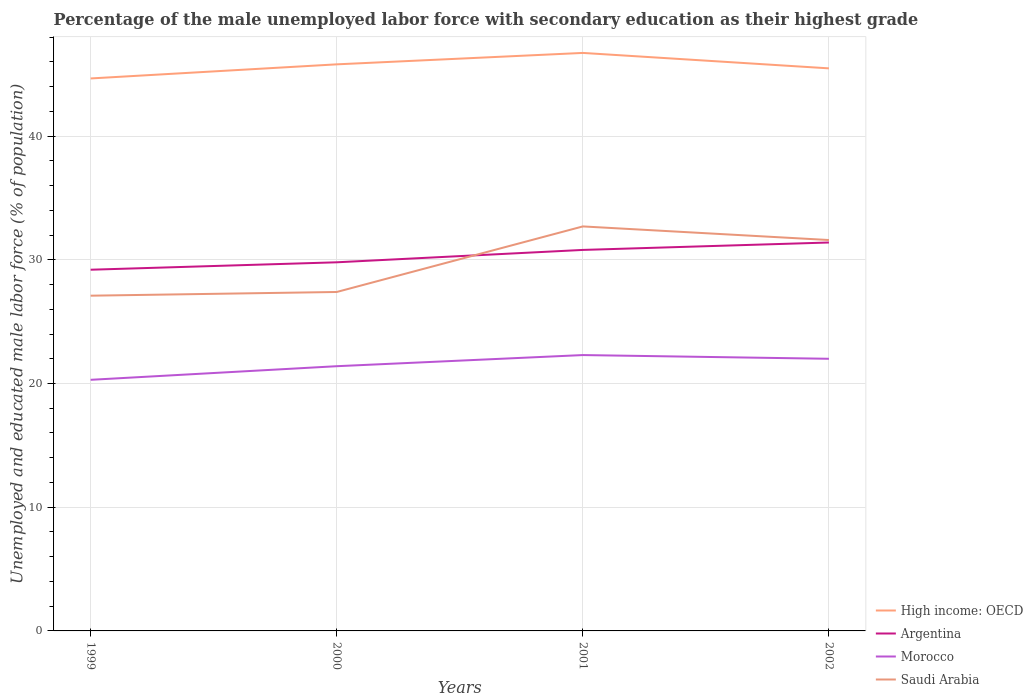Across all years, what is the maximum percentage of the unemployed male labor force with secondary education in Argentina?
Your answer should be very brief. 29.2. What is the total percentage of the unemployed male labor force with secondary education in High income: OECD in the graph?
Your answer should be very brief. -0.92. What is the difference between the highest and the second highest percentage of the unemployed male labor force with secondary education in Morocco?
Your answer should be very brief. 2. What is the difference between the highest and the lowest percentage of the unemployed male labor force with secondary education in Morocco?
Your answer should be compact. 2. Is the percentage of the unemployed male labor force with secondary education in High income: OECD strictly greater than the percentage of the unemployed male labor force with secondary education in Morocco over the years?
Provide a succinct answer. No. How many lines are there?
Provide a short and direct response. 4. Are the values on the major ticks of Y-axis written in scientific E-notation?
Your answer should be compact. No. Does the graph contain any zero values?
Give a very brief answer. No. Does the graph contain grids?
Give a very brief answer. Yes. Where does the legend appear in the graph?
Make the answer very short. Bottom right. How many legend labels are there?
Keep it short and to the point. 4. How are the legend labels stacked?
Your answer should be compact. Vertical. What is the title of the graph?
Offer a terse response. Percentage of the male unemployed labor force with secondary education as their highest grade. What is the label or title of the Y-axis?
Offer a terse response. Unemployed and educated male labor force (% of population). What is the Unemployed and educated male labor force (% of population) in High income: OECD in 1999?
Offer a terse response. 44.66. What is the Unemployed and educated male labor force (% of population) of Argentina in 1999?
Provide a short and direct response. 29.2. What is the Unemployed and educated male labor force (% of population) of Morocco in 1999?
Make the answer very short. 20.3. What is the Unemployed and educated male labor force (% of population) of Saudi Arabia in 1999?
Provide a succinct answer. 27.1. What is the Unemployed and educated male labor force (% of population) of High income: OECD in 2000?
Your answer should be compact. 45.8. What is the Unemployed and educated male labor force (% of population) in Argentina in 2000?
Give a very brief answer. 29.8. What is the Unemployed and educated male labor force (% of population) in Morocco in 2000?
Provide a succinct answer. 21.4. What is the Unemployed and educated male labor force (% of population) of Saudi Arabia in 2000?
Ensure brevity in your answer.  27.4. What is the Unemployed and educated male labor force (% of population) of High income: OECD in 2001?
Offer a very short reply. 46.73. What is the Unemployed and educated male labor force (% of population) in Argentina in 2001?
Make the answer very short. 30.8. What is the Unemployed and educated male labor force (% of population) in Morocco in 2001?
Offer a very short reply. 22.3. What is the Unemployed and educated male labor force (% of population) in Saudi Arabia in 2001?
Offer a very short reply. 32.7. What is the Unemployed and educated male labor force (% of population) of High income: OECD in 2002?
Ensure brevity in your answer.  45.48. What is the Unemployed and educated male labor force (% of population) of Argentina in 2002?
Provide a succinct answer. 31.4. What is the Unemployed and educated male labor force (% of population) of Saudi Arabia in 2002?
Keep it short and to the point. 31.6. Across all years, what is the maximum Unemployed and educated male labor force (% of population) of High income: OECD?
Make the answer very short. 46.73. Across all years, what is the maximum Unemployed and educated male labor force (% of population) in Argentina?
Your response must be concise. 31.4. Across all years, what is the maximum Unemployed and educated male labor force (% of population) in Morocco?
Your answer should be compact. 22.3. Across all years, what is the maximum Unemployed and educated male labor force (% of population) in Saudi Arabia?
Provide a short and direct response. 32.7. Across all years, what is the minimum Unemployed and educated male labor force (% of population) of High income: OECD?
Your answer should be very brief. 44.66. Across all years, what is the minimum Unemployed and educated male labor force (% of population) in Argentina?
Provide a short and direct response. 29.2. Across all years, what is the minimum Unemployed and educated male labor force (% of population) in Morocco?
Provide a short and direct response. 20.3. Across all years, what is the minimum Unemployed and educated male labor force (% of population) in Saudi Arabia?
Ensure brevity in your answer.  27.1. What is the total Unemployed and educated male labor force (% of population) in High income: OECD in the graph?
Make the answer very short. 182.67. What is the total Unemployed and educated male labor force (% of population) of Argentina in the graph?
Keep it short and to the point. 121.2. What is the total Unemployed and educated male labor force (% of population) in Morocco in the graph?
Ensure brevity in your answer.  86. What is the total Unemployed and educated male labor force (% of population) of Saudi Arabia in the graph?
Offer a very short reply. 118.8. What is the difference between the Unemployed and educated male labor force (% of population) in High income: OECD in 1999 and that in 2000?
Your answer should be compact. -1.14. What is the difference between the Unemployed and educated male labor force (% of population) in Morocco in 1999 and that in 2000?
Your answer should be very brief. -1.1. What is the difference between the Unemployed and educated male labor force (% of population) in Saudi Arabia in 1999 and that in 2000?
Offer a very short reply. -0.3. What is the difference between the Unemployed and educated male labor force (% of population) of High income: OECD in 1999 and that in 2001?
Give a very brief answer. -2.06. What is the difference between the Unemployed and educated male labor force (% of population) in Argentina in 1999 and that in 2001?
Your answer should be compact. -1.6. What is the difference between the Unemployed and educated male labor force (% of population) of Morocco in 1999 and that in 2001?
Your answer should be very brief. -2. What is the difference between the Unemployed and educated male labor force (% of population) in High income: OECD in 1999 and that in 2002?
Provide a succinct answer. -0.82. What is the difference between the Unemployed and educated male labor force (% of population) in Argentina in 1999 and that in 2002?
Keep it short and to the point. -2.2. What is the difference between the Unemployed and educated male labor force (% of population) of Saudi Arabia in 1999 and that in 2002?
Give a very brief answer. -4.5. What is the difference between the Unemployed and educated male labor force (% of population) of High income: OECD in 2000 and that in 2001?
Your answer should be very brief. -0.92. What is the difference between the Unemployed and educated male labor force (% of population) in High income: OECD in 2000 and that in 2002?
Make the answer very short. 0.32. What is the difference between the Unemployed and educated male labor force (% of population) of Argentina in 2000 and that in 2002?
Provide a succinct answer. -1.6. What is the difference between the Unemployed and educated male labor force (% of population) of High income: OECD in 2001 and that in 2002?
Keep it short and to the point. 1.25. What is the difference between the Unemployed and educated male labor force (% of population) of Argentina in 2001 and that in 2002?
Offer a terse response. -0.6. What is the difference between the Unemployed and educated male labor force (% of population) in High income: OECD in 1999 and the Unemployed and educated male labor force (% of population) in Argentina in 2000?
Offer a very short reply. 14.86. What is the difference between the Unemployed and educated male labor force (% of population) of High income: OECD in 1999 and the Unemployed and educated male labor force (% of population) of Morocco in 2000?
Keep it short and to the point. 23.26. What is the difference between the Unemployed and educated male labor force (% of population) in High income: OECD in 1999 and the Unemployed and educated male labor force (% of population) in Saudi Arabia in 2000?
Keep it short and to the point. 17.26. What is the difference between the Unemployed and educated male labor force (% of population) in Argentina in 1999 and the Unemployed and educated male labor force (% of population) in Morocco in 2000?
Provide a short and direct response. 7.8. What is the difference between the Unemployed and educated male labor force (% of population) in High income: OECD in 1999 and the Unemployed and educated male labor force (% of population) in Argentina in 2001?
Ensure brevity in your answer.  13.86. What is the difference between the Unemployed and educated male labor force (% of population) in High income: OECD in 1999 and the Unemployed and educated male labor force (% of population) in Morocco in 2001?
Your answer should be compact. 22.36. What is the difference between the Unemployed and educated male labor force (% of population) in High income: OECD in 1999 and the Unemployed and educated male labor force (% of population) in Saudi Arabia in 2001?
Ensure brevity in your answer.  11.96. What is the difference between the Unemployed and educated male labor force (% of population) of Morocco in 1999 and the Unemployed and educated male labor force (% of population) of Saudi Arabia in 2001?
Ensure brevity in your answer.  -12.4. What is the difference between the Unemployed and educated male labor force (% of population) of High income: OECD in 1999 and the Unemployed and educated male labor force (% of population) of Argentina in 2002?
Keep it short and to the point. 13.26. What is the difference between the Unemployed and educated male labor force (% of population) in High income: OECD in 1999 and the Unemployed and educated male labor force (% of population) in Morocco in 2002?
Make the answer very short. 22.66. What is the difference between the Unemployed and educated male labor force (% of population) in High income: OECD in 1999 and the Unemployed and educated male labor force (% of population) in Saudi Arabia in 2002?
Offer a terse response. 13.06. What is the difference between the Unemployed and educated male labor force (% of population) in Argentina in 1999 and the Unemployed and educated male labor force (% of population) in Saudi Arabia in 2002?
Your response must be concise. -2.4. What is the difference between the Unemployed and educated male labor force (% of population) in High income: OECD in 2000 and the Unemployed and educated male labor force (% of population) in Argentina in 2001?
Your answer should be compact. 15. What is the difference between the Unemployed and educated male labor force (% of population) of High income: OECD in 2000 and the Unemployed and educated male labor force (% of population) of Morocco in 2001?
Make the answer very short. 23.5. What is the difference between the Unemployed and educated male labor force (% of population) of High income: OECD in 2000 and the Unemployed and educated male labor force (% of population) of Saudi Arabia in 2001?
Keep it short and to the point. 13.1. What is the difference between the Unemployed and educated male labor force (% of population) in Argentina in 2000 and the Unemployed and educated male labor force (% of population) in Morocco in 2001?
Your answer should be compact. 7.5. What is the difference between the Unemployed and educated male labor force (% of population) in Argentina in 2000 and the Unemployed and educated male labor force (% of population) in Saudi Arabia in 2001?
Your answer should be very brief. -2.9. What is the difference between the Unemployed and educated male labor force (% of population) of High income: OECD in 2000 and the Unemployed and educated male labor force (% of population) of Argentina in 2002?
Your response must be concise. 14.4. What is the difference between the Unemployed and educated male labor force (% of population) in High income: OECD in 2000 and the Unemployed and educated male labor force (% of population) in Morocco in 2002?
Provide a short and direct response. 23.8. What is the difference between the Unemployed and educated male labor force (% of population) of High income: OECD in 2000 and the Unemployed and educated male labor force (% of population) of Saudi Arabia in 2002?
Give a very brief answer. 14.2. What is the difference between the Unemployed and educated male labor force (% of population) in Argentina in 2000 and the Unemployed and educated male labor force (% of population) in Morocco in 2002?
Give a very brief answer. 7.8. What is the difference between the Unemployed and educated male labor force (% of population) of Argentina in 2000 and the Unemployed and educated male labor force (% of population) of Saudi Arabia in 2002?
Your answer should be compact. -1.8. What is the difference between the Unemployed and educated male labor force (% of population) in Morocco in 2000 and the Unemployed and educated male labor force (% of population) in Saudi Arabia in 2002?
Your answer should be very brief. -10.2. What is the difference between the Unemployed and educated male labor force (% of population) in High income: OECD in 2001 and the Unemployed and educated male labor force (% of population) in Argentina in 2002?
Give a very brief answer. 15.33. What is the difference between the Unemployed and educated male labor force (% of population) in High income: OECD in 2001 and the Unemployed and educated male labor force (% of population) in Morocco in 2002?
Ensure brevity in your answer.  24.73. What is the difference between the Unemployed and educated male labor force (% of population) in High income: OECD in 2001 and the Unemployed and educated male labor force (% of population) in Saudi Arabia in 2002?
Provide a short and direct response. 15.13. What is the difference between the Unemployed and educated male labor force (% of population) of Argentina in 2001 and the Unemployed and educated male labor force (% of population) of Morocco in 2002?
Make the answer very short. 8.8. What is the difference between the Unemployed and educated male labor force (% of population) of Morocco in 2001 and the Unemployed and educated male labor force (% of population) of Saudi Arabia in 2002?
Keep it short and to the point. -9.3. What is the average Unemployed and educated male labor force (% of population) in High income: OECD per year?
Provide a succinct answer. 45.67. What is the average Unemployed and educated male labor force (% of population) of Argentina per year?
Provide a short and direct response. 30.3. What is the average Unemployed and educated male labor force (% of population) in Morocco per year?
Offer a very short reply. 21.5. What is the average Unemployed and educated male labor force (% of population) in Saudi Arabia per year?
Your answer should be very brief. 29.7. In the year 1999, what is the difference between the Unemployed and educated male labor force (% of population) in High income: OECD and Unemployed and educated male labor force (% of population) in Argentina?
Your answer should be very brief. 15.46. In the year 1999, what is the difference between the Unemployed and educated male labor force (% of population) in High income: OECD and Unemployed and educated male labor force (% of population) in Morocco?
Offer a terse response. 24.36. In the year 1999, what is the difference between the Unemployed and educated male labor force (% of population) of High income: OECD and Unemployed and educated male labor force (% of population) of Saudi Arabia?
Make the answer very short. 17.56. In the year 1999, what is the difference between the Unemployed and educated male labor force (% of population) in Argentina and Unemployed and educated male labor force (% of population) in Saudi Arabia?
Keep it short and to the point. 2.1. In the year 2000, what is the difference between the Unemployed and educated male labor force (% of population) in High income: OECD and Unemployed and educated male labor force (% of population) in Argentina?
Offer a terse response. 16. In the year 2000, what is the difference between the Unemployed and educated male labor force (% of population) in High income: OECD and Unemployed and educated male labor force (% of population) in Morocco?
Offer a very short reply. 24.4. In the year 2000, what is the difference between the Unemployed and educated male labor force (% of population) in High income: OECD and Unemployed and educated male labor force (% of population) in Saudi Arabia?
Your answer should be very brief. 18.4. In the year 2000, what is the difference between the Unemployed and educated male labor force (% of population) of Morocco and Unemployed and educated male labor force (% of population) of Saudi Arabia?
Your answer should be very brief. -6. In the year 2001, what is the difference between the Unemployed and educated male labor force (% of population) of High income: OECD and Unemployed and educated male labor force (% of population) of Argentina?
Your response must be concise. 15.93. In the year 2001, what is the difference between the Unemployed and educated male labor force (% of population) of High income: OECD and Unemployed and educated male labor force (% of population) of Morocco?
Offer a very short reply. 24.43. In the year 2001, what is the difference between the Unemployed and educated male labor force (% of population) of High income: OECD and Unemployed and educated male labor force (% of population) of Saudi Arabia?
Offer a terse response. 14.03. In the year 2001, what is the difference between the Unemployed and educated male labor force (% of population) of Argentina and Unemployed and educated male labor force (% of population) of Morocco?
Provide a succinct answer. 8.5. In the year 2001, what is the difference between the Unemployed and educated male labor force (% of population) in Argentina and Unemployed and educated male labor force (% of population) in Saudi Arabia?
Make the answer very short. -1.9. In the year 2001, what is the difference between the Unemployed and educated male labor force (% of population) of Morocco and Unemployed and educated male labor force (% of population) of Saudi Arabia?
Offer a terse response. -10.4. In the year 2002, what is the difference between the Unemployed and educated male labor force (% of population) in High income: OECD and Unemployed and educated male labor force (% of population) in Argentina?
Make the answer very short. 14.08. In the year 2002, what is the difference between the Unemployed and educated male labor force (% of population) of High income: OECD and Unemployed and educated male labor force (% of population) of Morocco?
Provide a succinct answer. 23.48. In the year 2002, what is the difference between the Unemployed and educated male labor force (% of population) of High income: OECD and Unemployed and educated male labor force (% of population) of Saudi Arabia?
Offer a terse response. 13.88. In the year 2002, what is the difference between the Unemployed and educated male labor force (% of population) of Argentina and Unemployed and educated male labor force (% of population) of Saudi Arabia?
Make the answer very short. -0.2. What is the ratio of the Unemployed and educated male labor force (% of population) of High income: OECD in 1999 to that in 2000?
Keep it short and to the point. 0.98. What is the ratio of the Unemployed and educated male labor force (% of population) of Argentina in 1999 to that in 2000?
Give a very brief answer. 0.98. What is the ratio of the Unemployed and educated male labor force (% of population) in Morocco in 1999 to that in 2000?
Provide a succinct answer. 0.95. What is the ratio of the Unemployed and educated male labor force (% of population) in High income: OECD in 1999 to that in 2001?
Provide a short and direct response. 0.96. What is the ratio of the Unemployed and educated male labor force (% of population) in Argentina in 1999 to that in 2001?
Offer a very short reply. 0.95. What is the ratio of the Unemployed and educated male labor force (% of population) in Morocco in 1999 to that in 2001?
Provide a succinct answer. 0.91. What is the ratio of the Unemployed and educated male labor force (% of population) in Saudi Arabia in 1999 to that in 2001?
Give a very brief answer. 0.83. What is the ratio of the Unemployed and educated male labor force (% of population) in High income: OECD in 1999 to that in 2002?
Offer a very short reply. 0.98. What is the ratio of the Unemployed and educated male labor force (% of population) in Argentina in 1999 to that in 2002?
Your response must be concise. 0.93. What is the ratio of the Unemployed and educated male labor force (% of population) in Morocco in 1999 to that in 2002?
Offer a terse response. 0.92. What is the ratio of the Unemployed and educated male labor force (% of population) of Saudi Arabia in 1999 to that in 2002?
Ensure brevity in your answer.  0.86. What is the ratio of the Unemployed and educated male labor force (% of population) in High income: OECD in 2000 to that in 2001?
Offer a terse response. 0.98. What is the ratio of the Unemployed and educated male labor force (% of population) in Argentina in 2000 to that in 2001?
Your response must be concise. 0.97. What is the ratio of the Unemployed and educated male labor force (% of population) in Morocco in 2000 to that in 2001?
Give a very brief answer. 0.96. What is the ratio of the Unemployed and educated male labor force (% of population) of Saudi Arabia in 2000 to that in 2001?
Keep it short and to the point. 0.84. What is the ratio of the Unemployed and educated male labor force (% of population) of High income: OECD in 2000 to that in 2002?
Ensure brevity in your answer.  1.01. What is the ratio of the Unemployed and educated male labor force (% of population) in Argentina in 2000 to that in 2002?
Provide a succinct answer. 0.95. What is the ratio of the Unemployed and educated male labor force (% of population) of Morocco in 2000 to that in 2002?
Offer a very short reply. 0.97. What is the ratio of the Unemployed and educated male labor force (% of population) in Saudi Arabia in 2000 to that in 2002?
Give a very brief answer. 0.87. What is the ratio of the Unemployed and educated male labor force (% of population) in High income: OECD in 2001 to that in 2002?
Provide a succinct answer. 1.03. What is the ratio of the Unemployed and educated male labor force (% of population) in Argentina in 2001 to that in 2002?
Your answer should be compact. 0.98. What is the ratio of the Unemployed and educated male labor force (% of population) in Morocco in 2001 to that in 2002?
Your answer should be very brief. 1.01. What is the ratio of the Unemployed and educated male labor force (% of population) in Saudi Arabia in 2001 to that in 2002?
Your answer should be very brief. 1.03. What is the difference between the highest and the second highest Unemployed and educated male labor force (% of population) in High income: OECD?
Give a very brief answer. 0.92. What is the difference between the highest and the second highest Unemployed and educated male labor force (% of population) in Morocco?
Ensure brevity in your answer.  0.3. What is the difference between the highest and the second highest Unemployed and educated male labor force (% of population) of Saudi Arabia?
Your response must be concise. 1.1. What is the difference between the highest and the lowest Unemployed and educated male labor force (% of population) of High income: OECD?
Offer a very short reply. 2.06. What is the difference between the highest and the lowest Unemployed and educated male labor force (% of population) in Argentina?
Provide a short and direct response. 2.2. What is the difference between the highest and the lowest Unemployed and educated male labor force (% of population) of Saudi Arabia?
Your answer should be very brief. 5.6. 